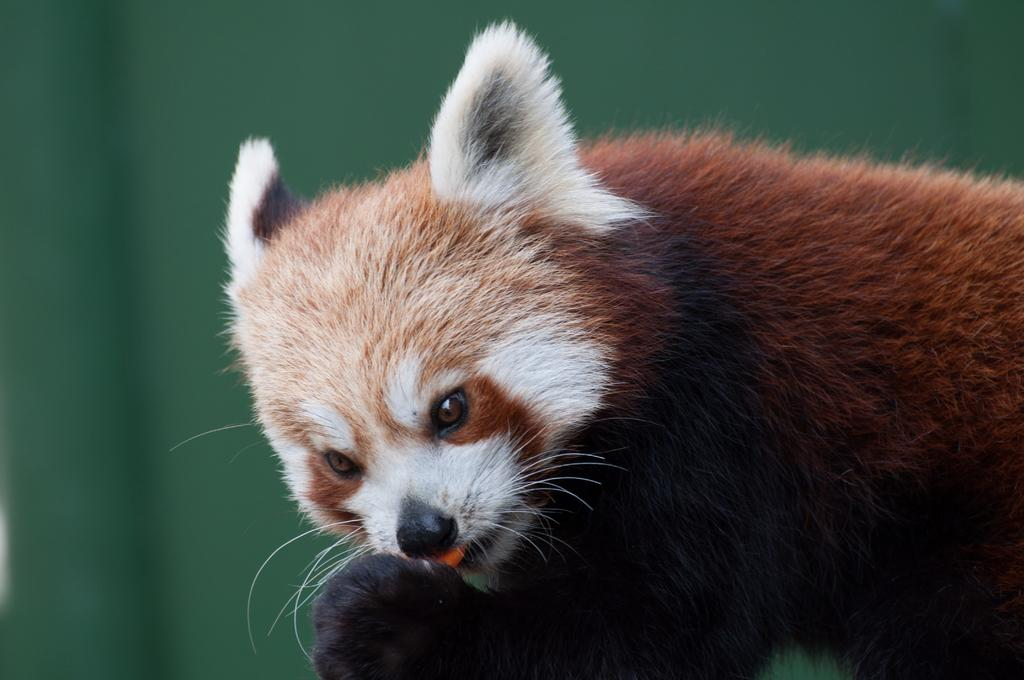What type of animal can be seen in the image? There is a brown and white color animal in the image. What is the color of the background in the image? The background of the image is green. What type of bird can be seen flying in the image? There is no bird present in the image; it features a brown and white color animal. What type of train can be seen passing by in the image? There is no train present in the image; it features a brown and white color animal in a green background. 